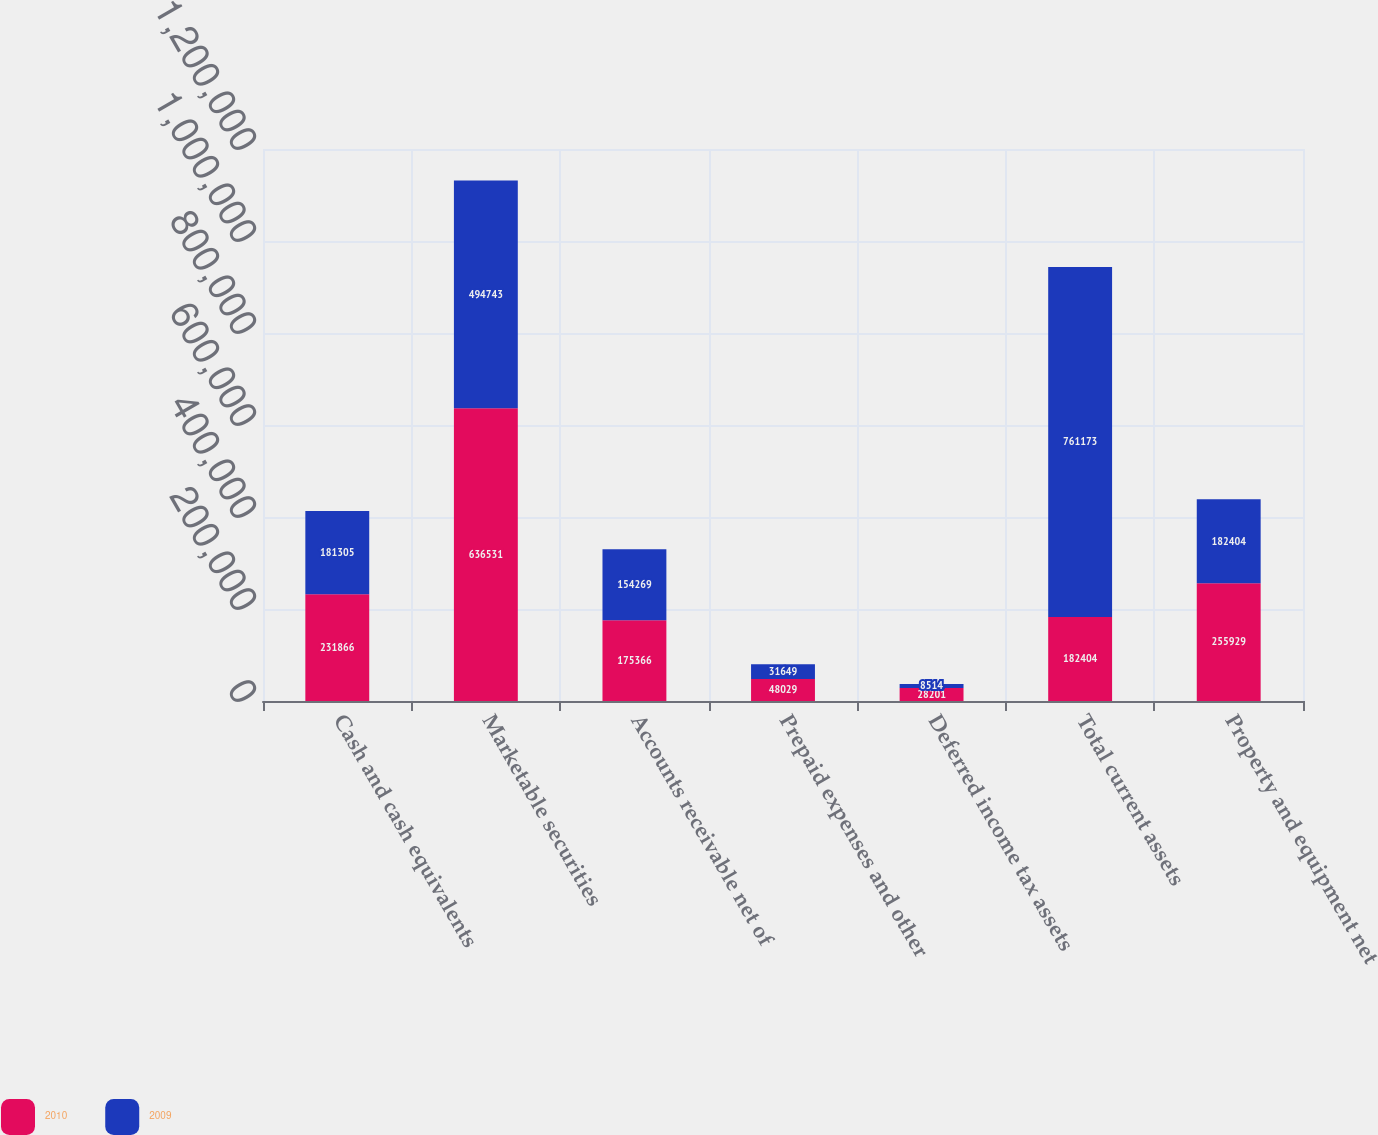<chart> <loc_0><loc_0><loc_500><loc_500><stacked_bar_chart><ecel><fcel>Cash and cash equivalents<fcel>Marketable securities<fcel>Accounts receivable net of<fcel>Prepaid expenses and other<fcel>Deferred income tax assets<fcel>Total current assets<fcel>Property and equipment net<nl><fcel>2010<fcel>231866<fcel>636531<fcel>175366<fcel>48029<fcel>28201<fcel>182404<fcel>255929<nl><fcel>2009<fcel>181305<fcel>494743<fcel>154269<fcel>31649<fcel>8514<fcel>761173<fcel>182404<nl></chart> 